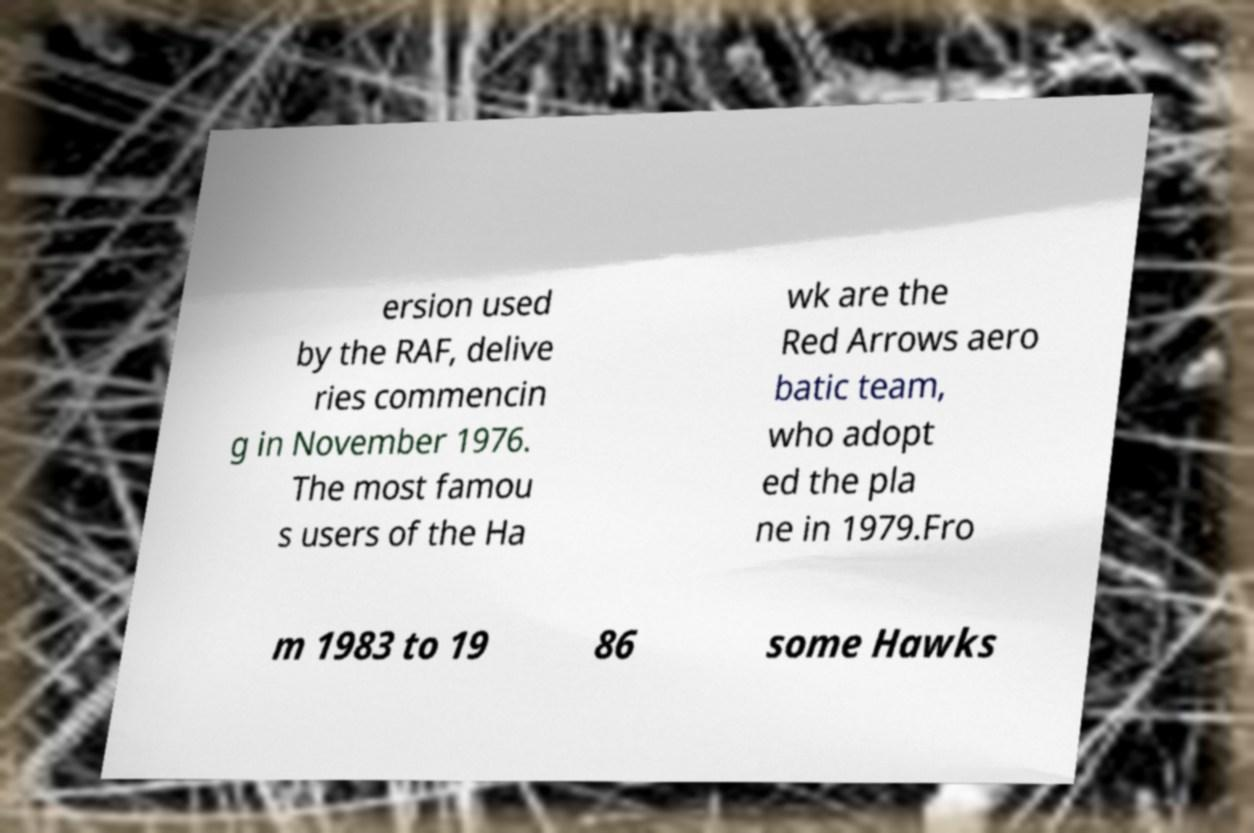Could you assist in decoding the text presented in this image and type it out clearly? ersion used by the RAF, delive ries commencin g in November 1976. The most famou s users of the Ha wk are the Red Arrows aero batic team, who adopt ed the pla ne in 1979.Fro m 1983 to 19 86 some Hawks 